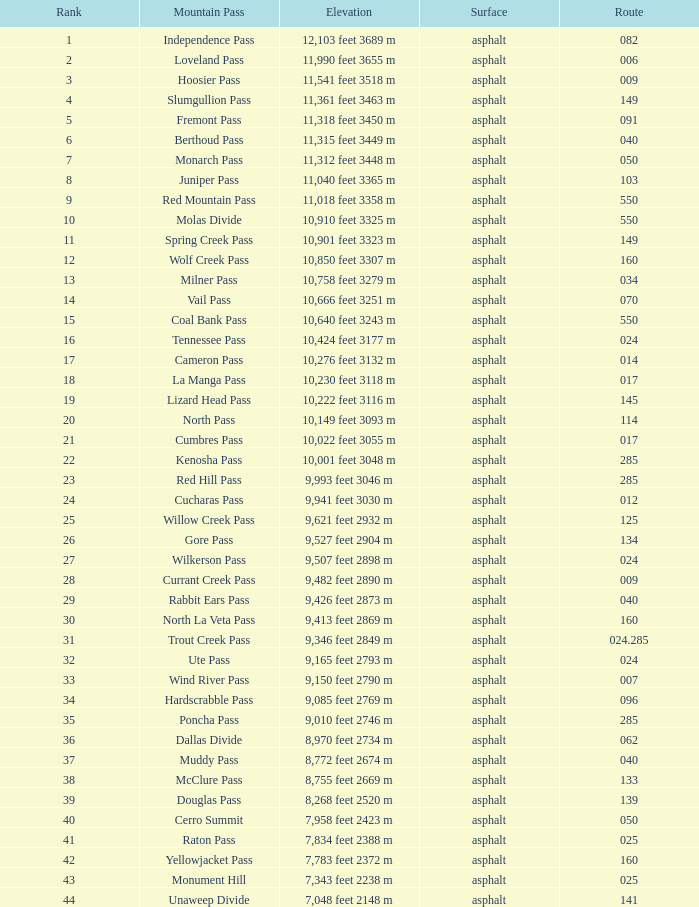What is the Mountain Pass with a 21 Rank? Cumbres Pass. 